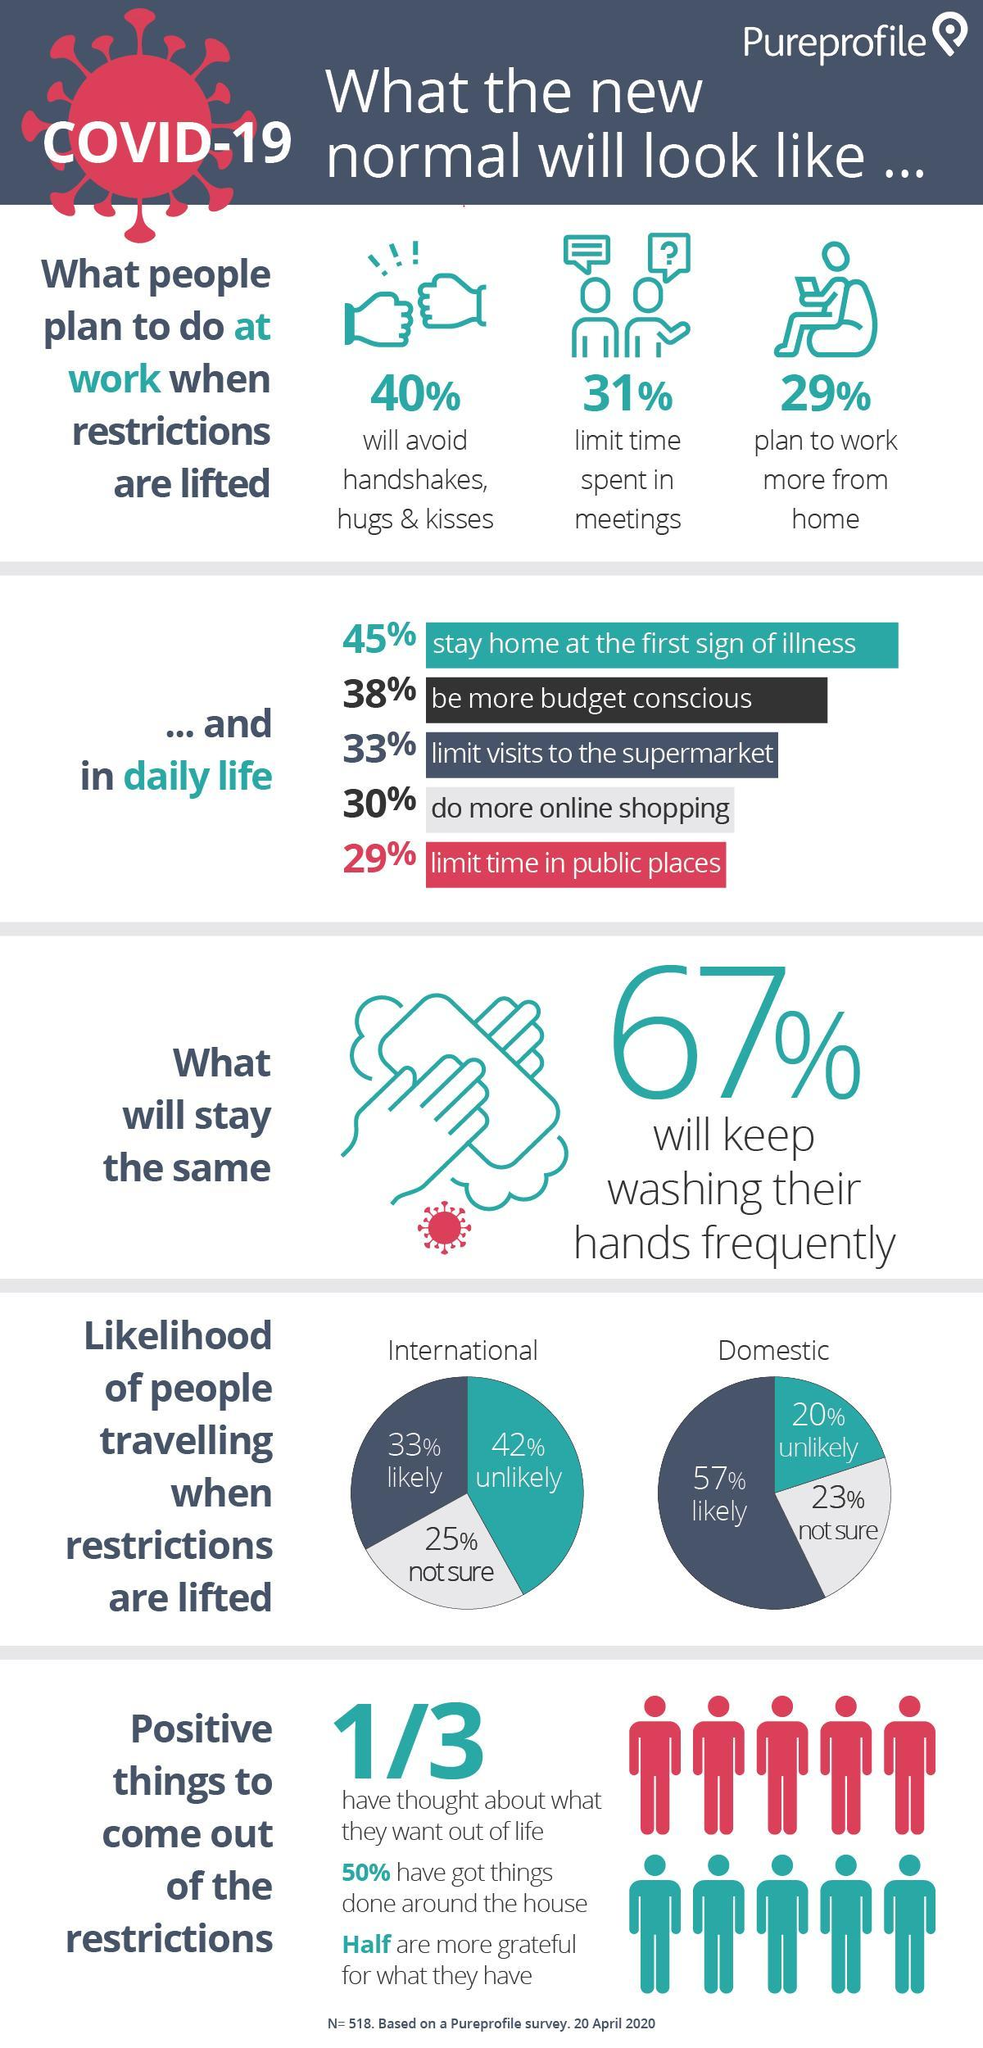What percentage of people did not stay home after the first sight of illness?
Answer the question with a short phrase. 55% The percentage of "likely" is highest in which type of travel -domestic, international? domestic What percentage of people avoid handshakes, hugs & kisses? 40% The percentage of "not sure" is highest in which type of travel -domestic, international? international What percentage of people plan to work more from home? 29% How many peoples are red in this infographic? 5 What percentage of people prefer offline shopping? 70% What percentage of people limit the time spent in meetings? 31% 